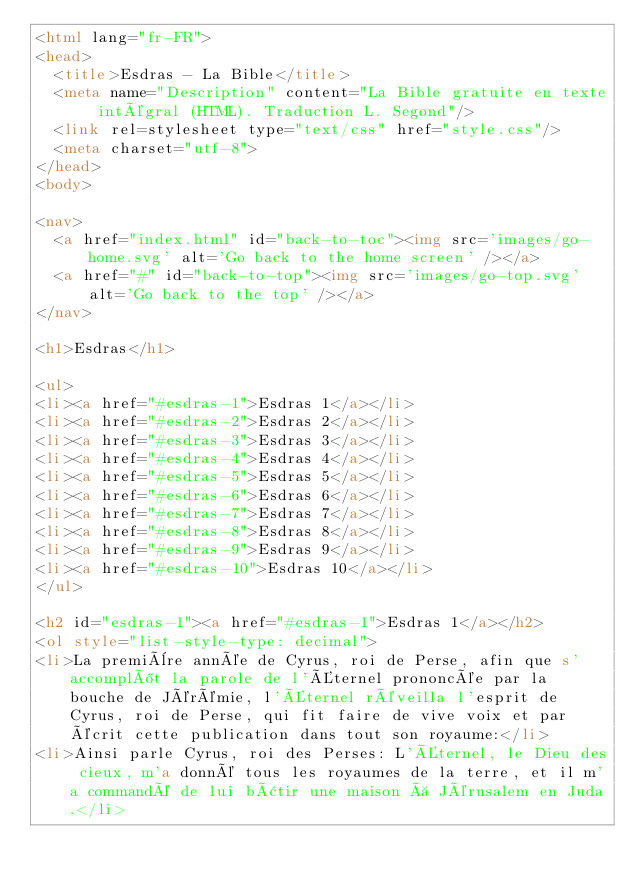<code> <loc_0><loc_0><loc_500><loc_500><_HTML_><html lang="fr-FR">
<head>
  <title>Esdras - La Bible</title>
  <meta name="Description" content="La Bible gratuite en texte intégral (HTML). Traduction L. Segond"/>
  <link rel=stylesheet type="text/css" href="style.css"/>
  <meta charset="utf-8">
</head>
<body>

<nav>
  <a href="index.html" id="back-to-toc"><img src='images/go-home.svg' alt='Go back to the home screen' /></a>
  <a href="#" id="back-to-top"><img src='images/go-top.svg' alt='Go back to the top' /></a>
</nav>

<h1>Esdras</h1>

<ul>
<li><a href="#esdras-1">Esdras 1</a></li>
<li><a href="#esdras-2">Esdras 2</a></li>
<li><a href="#esdras-3">Esdras 3</a></li>
<li><a href="#esdras-4">Esdras 4</a></li>
<li><a href="#esdras-5">Esdras 5</a></li>
<li><a href="#esdras-6">Esdras 6</a></li>
<li><a href="#esdras-7">Esdras 7</a></li>
<li><a href="#esdras-8">Esdras 8</a></li>
<li><a href="#esdras-9">Esdras 9</a></li>
<li><a href="#esdras-10">Esdras 10</a></li>
</ul>

<h2 id="esdras-1"><a href="#esdras-1">Esdras 1</a></h2>
<ol style="list-style-type: decimal">
<li>La première année de Cyrus, roi de Perse, afin que s'accomplît la parole de l'Éternel prononcée par la bouche de Jérémie, l'Éternel réveilla l'esprit de Cyrus, roi de Perse, qui fit faire de vive voix et par écrit cette publication dans tout son royaume:</li>
<li>Ainsi parle Cyrus, roi des Perses: L'Éternel, le Dieu des cieux, m'a donné tous les royaumes de la terre, et il m'a commandé de lui bâtir une maison à Jérusalem en Juda.</li></code> 